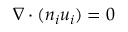Convert formula to latex. <formula><loc_0><loc_0><loc_500><loc_500>\nabla \cdot ( n _ { i } u _ { i } ) = 0</formula> 